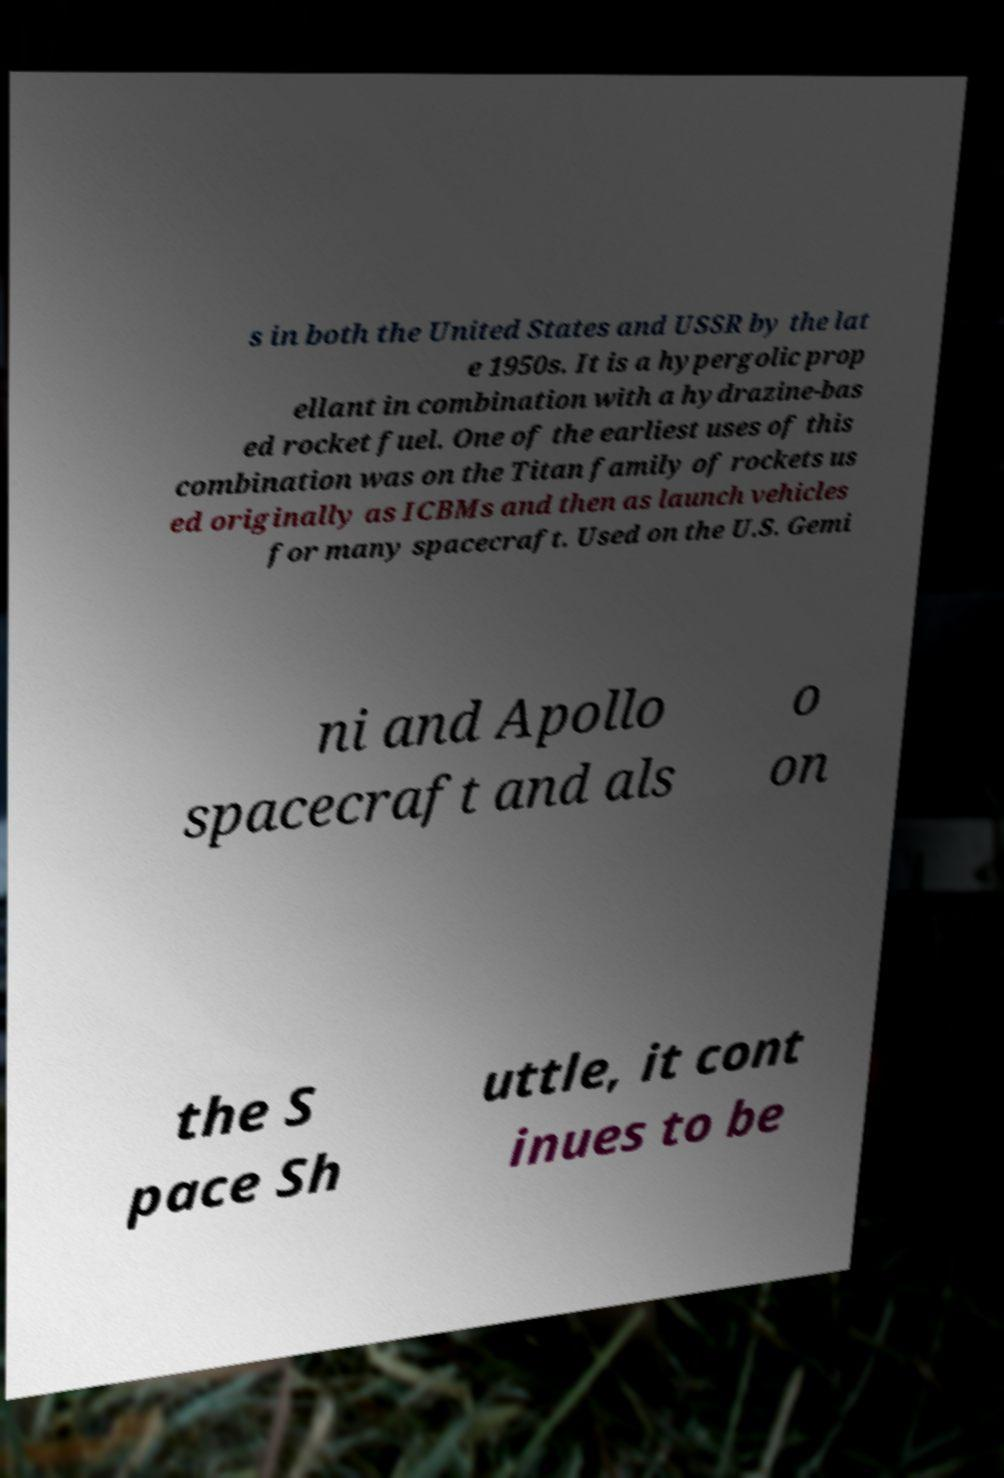Please read and relay the text visible in this image. What does it say? s in both the United States and USSR by the lat e 1950s. It is a hypergolic prop ellant in combination with a hydrazine-bas ed rocket fuel. One of the earliest uses of this combination was on the Titan family of rockets us ed originally as ICBMs and then as launch vehicles for many spacecraft. Used on the U.S. Gemi ni and Apollo spacecraft and als o on the S pace Sh uttle, it cont inues to be 